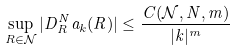<formula> <loc_0><loc_0><loc_500><loc_500>\sup _ { R \in \mathcal { N } } | D ^ { N } _ { R } a _ { k } ( R ) | \leq \frac { C ( \mathcal { N } , N , m ) } { | k | ^ { m } }</formula> 